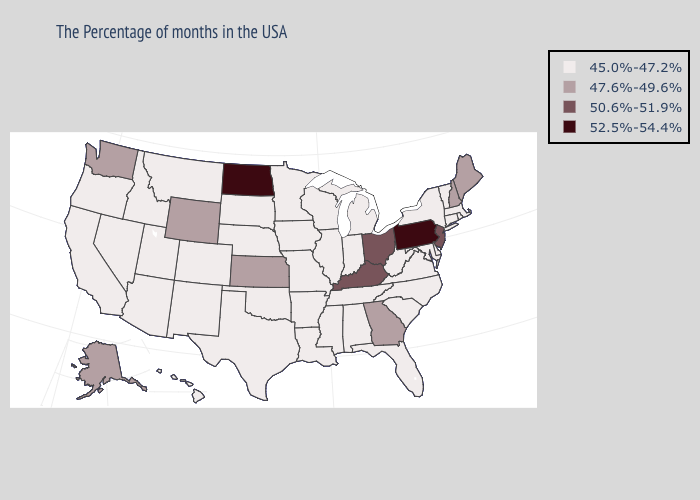Is the legend a continuous bar?
Be succinct. No. Among the states that border New Hampshire , does Vermont have the highest value?
Give a very brief answer. No. What is the lowest value in the Northeast?
Keep it brief. 45.0%-47.2%. Name the states that have a value in the range 47.6%-49.6%?
Answer briefly. Maine, New Hampshire, Georgia, Kansas, Wyoming, Washington, Alaska. Does New Mexico have the lowest value in the USA?
Short answer required. Yes. Which states hav the highest value in the South?
Short answer required. Kentucky. Among the states that border Idaho , does Montana have the lowest value?
Answer briefly. Yes. Among the states that border Connecticut , which have the highest value?
Keep it brief. Massachusetts, Rhode Island, New York. Does New Jersey have the lowest value in the Northeast?
Give a very brief answer. No. Is the legend a continuous bar?
Concise answer only. No. Does Georgia have the lowest value in the USA?
Write a very short answer. No. Name the states that have a value in the range 52.5%-54.4%?
Write a very short answer. Pennsylvania, North Dakota. Name the states that have a value in the range 47.6%-49.6%?
Answer briefly. Maine, New Hampshire, Georgia, Kansas, Wyoming, Washington, Alaska. 